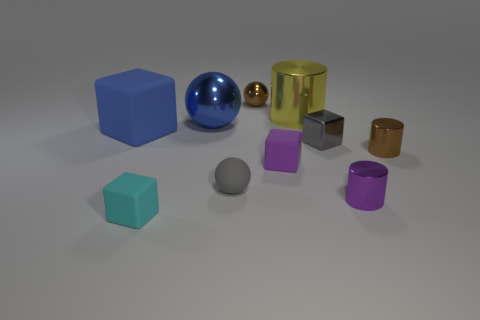What size is the ball that is the same color as the small shiny cube?
Your answer should be compact. Small. What number of tiny spheres are the same color as the large sphere?
Ensure brevity in your answer.  0. How many things are small gray objects that are to the right of the purple block or cyan metallic blocks?
Offer a very short reply. 1. How big is the metal cylinder that is behind the large blue matte block?
Provide a succinct answer. Large. Is the number of blue objects less than the number of blue metallic balls?
Provide a succinct answer. No. Is the brown object that is behind the big blue metal ball made of the same material as the purple thing in front of the purple block?
Ensure brevity in your answer.  Yes. What shape is the small gray metal object that is in front of the brown shiny object on the left side of the tiny brown thing that is in front of the big cube?
Your response must be concise. Cube. What number of tiny purple cylinders have the same material as the tiny brown ball?
Offer a very short reply. 1. There is a ball in front of the big blue shiny thing; what number of yellow objects are in front of it?
Your answer should be compact. 0. There is a small sphere on the left side of the brown sphere; does it have the same color as the tiny cube on the right side of the purple matte object?
Your answer should be very brief. Yes. 